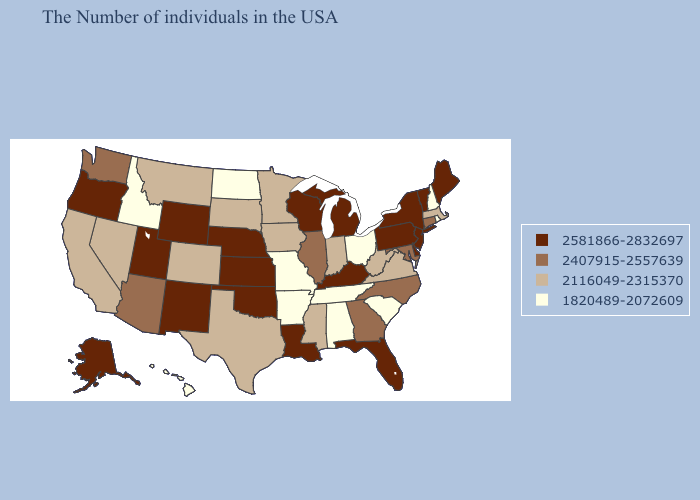Does West Virginia have a higher value than Washington?
Answer briefly. No. Does Indiana have a lower value than Tennessee?
Answer briefly. No. Which states have the highest value in the USA?
Give a very brief answer. Maine, Vermont, New York, New Jersey, Delaware, Pennsylvania, Florida, Michigan, Kentucky, Wisconsin, Louisiana, Kansas, Nebraska, Oklahoma, Wyoming, New Mexico, Utah, Oregon, Alaska. Name the states that have a value in the range 1820489-2072609?
Quick response, please. Rhode Island, New Hampshire, South Carolina, Ohio, Alabama, Tennessee, Missouri, Arkansas, North Dakota, Idaho, Hawaii. Which states hav the highest value in the South?
Answer briefly. Delaware, Florida, Kentucky, Louisiana, Oklahoma. Does New Hampshire have the same value as Utah?
Short answer required. No. What is the value of Vermont?
Give a very brief answer. 2581866-2832697. What is the highest value in the USA?
Write a very short answer. 2581866-2832697. Among the states that border Colorado , does Oklahoma have the highest value?
Keep it brief. Yes. Does the map have missing data?
Short answer required. No. Does Louisiana have the highest value in the South?
Be succinct. Yes. What is the lowest value in the Northeast?
Give a very brief answer. 1820489-2072609. What is the value of Wyoming?
Give a very brief answer. 2581866-2832697. What is the value of Arkansas?
Write a very short answer. 1820489-2072609. Name the states that have a value in the range 1820489-2072609?
Answer briefly. Rhode Island, New Hampshire, South Carolina, Ohio, Alabama, Tennessee, Missouri, Arkansas, North Dakota, Idaho, Hawaii. 